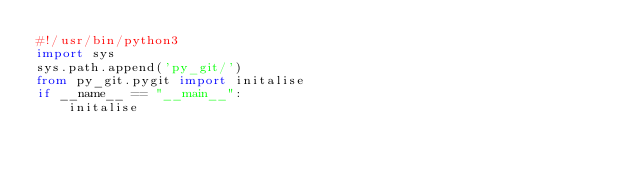<code> <loc_0><loc_0><loc_500><loc_500><_Python_>#!/usr/bin/python3
import sys
sys.path.append('py_git/')
from py_git.pygit import initalise
if __name__ == "__main__":
    initalise
</code> 